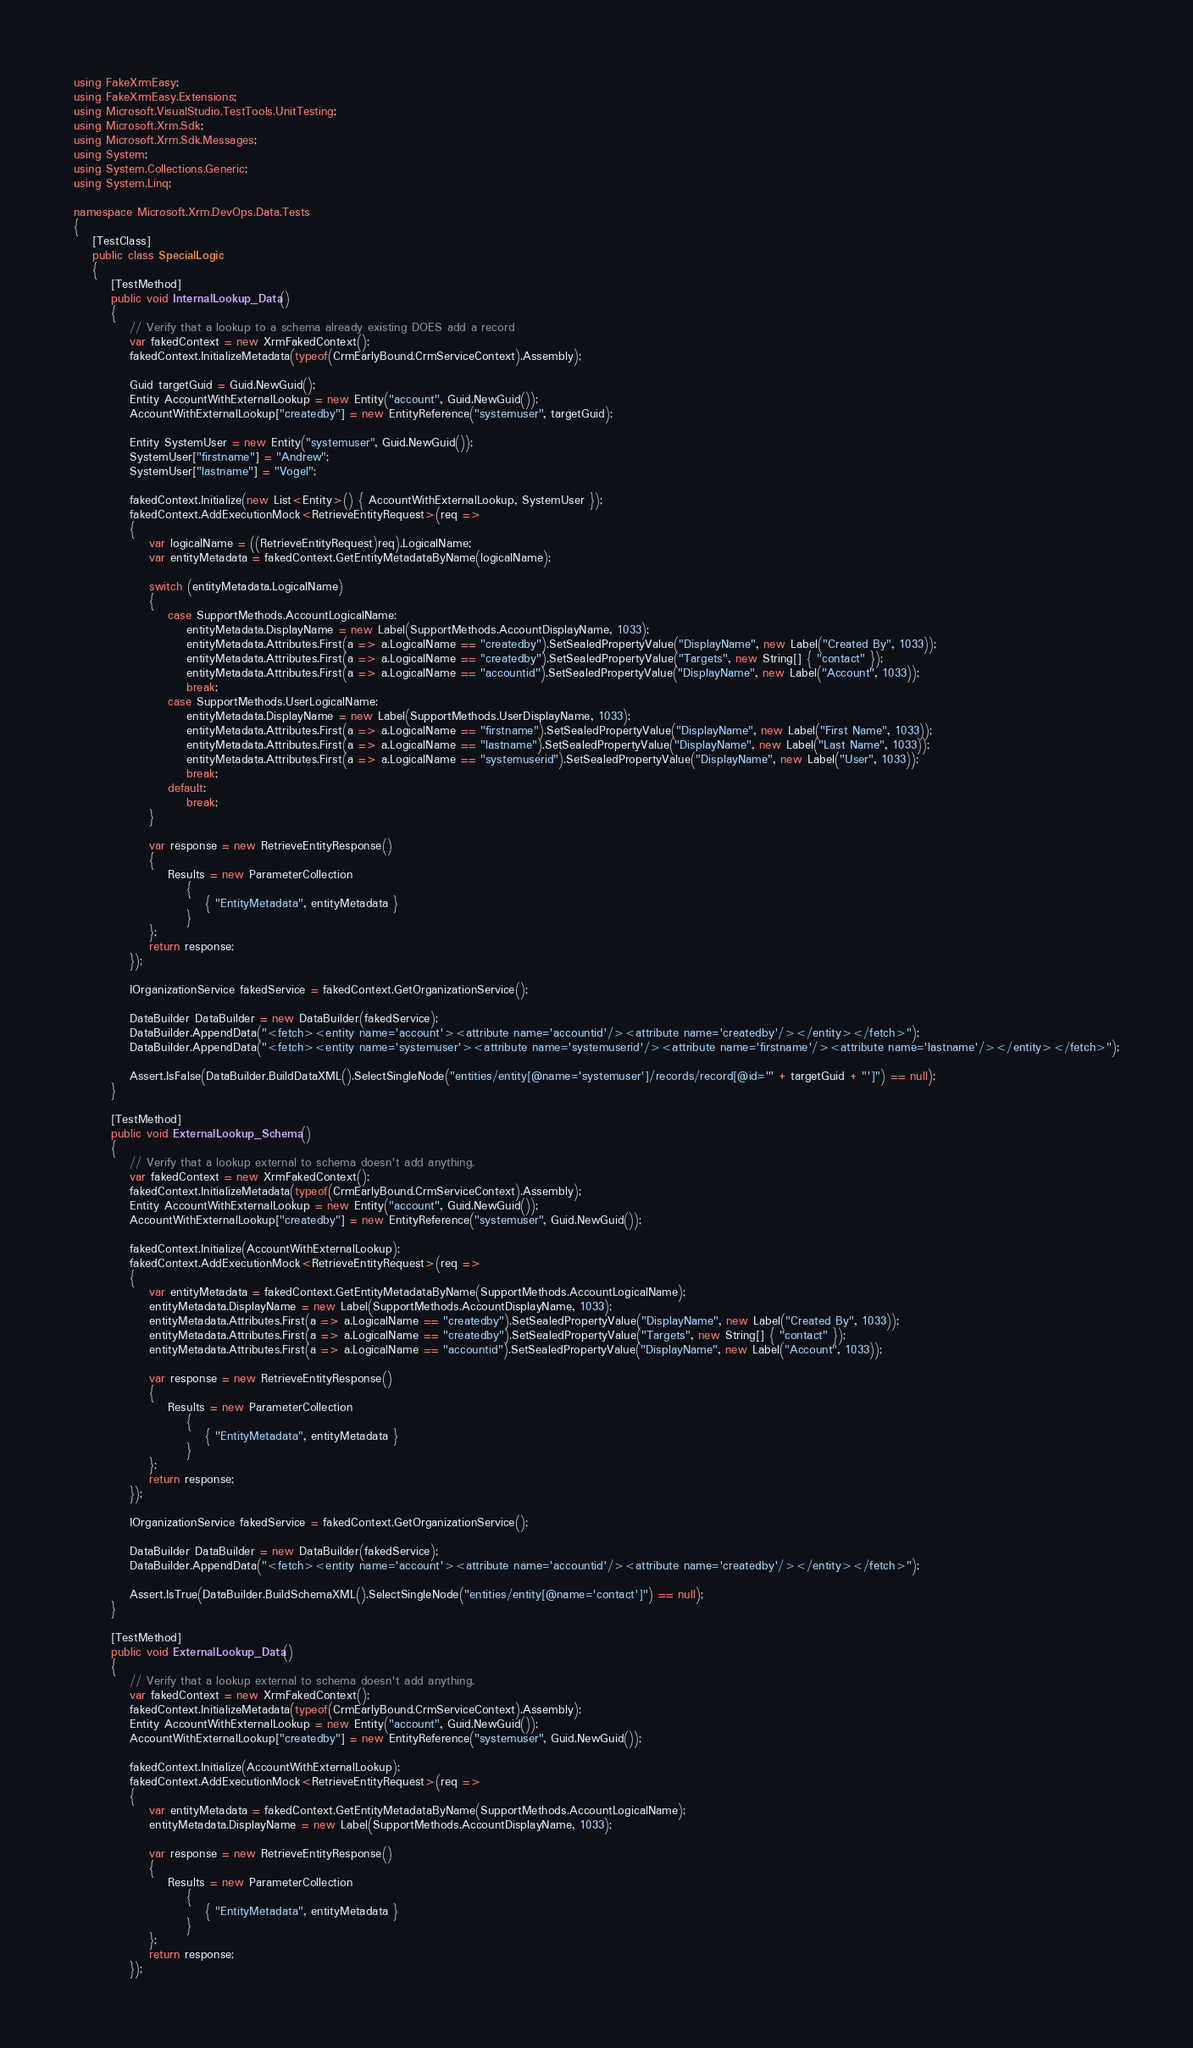<code> <loc_0><loc_0><loc_500><loc_500><_C#_>using FakeXrmEasy;
using FakeXrmEasy.Extensions;
using Microsoft.VisualStudio.TestTools.UnitTesting;
using Microsoft.Xrm.Sdk;
using Microsoft.Xrm.Sdk.Messages;
using System;
using System.Collections.Generic;
using System.Linq;

namespace Microsoft.Xrm.DevOps.Data.Tests
{
    [TestClass]
    public class SpecialLogic
    {
        [TestMethod]
        public void InternalLookup_Data()
        {
            // Verify that a lookup to a schema already existing DOES add a record
            var fakedContext = new XrmFakedContext();
            fakedContext.InitializeMetadata(typeof(CrmEarlyBound.CrmServiceContext).Assembly);

            Guid targetGuid = Guid.NewGuid();
            Entity AccountWithExternalLookup = new Entity("account", Guid.NewGuid());
            AccountWithExternalLookup["createdby"] = new EntityReference("systemuser", targetGuid);

            Entity SystemUser = new Entity("systemuser", Guid.NewGuid());
            SystemUser["firstname"] = "Andrew";
            SystemUser["lastname"] = "Vogel";

            fakedContext.Initialize(new List<Entity>() { AccountWithExternalLookup, SystemUser });
            fakedContext.AddExecutionMock<RetrieveEntityRequest>(req =>
            {
                var logicalName = ((RetrieveEntityRequest)req).LogicalName;
                var entityMetadata = fakedContext.GetEntityMetadataByName(logicalName);

                switch (entityMetadata.LogicalName)
                {
                    case SupportMethods.AccountLogicalName:
                        entityMetadata.DisplayName = new Label(SupportMethods.AccountDisplayName, 1033);
                        entityMetadata.Attributes.First(a => a.LogicalName == "createdby").SetSealedPropertyValue("DisplayName", new Label("Created By", 1033));
                        entityMetadata.Attributes.First(a => a.LogicalName == "createdby").SetSealedPropertyValue("Targets", new String[] { "contact" });
                        entityMetadata.Attributes.First(a => a.LogicalName == "accountid").SetSealedPropertyValue("DisplayName", new Label("Account", 1033));
                        break;
                    case SupportMethods.UserLogicalName:
                        entityMetadata.DisplayName = new Label(SupportMethods.UserDisplayName, 1033);
                        entityMetadata.Attributes.First(a => a.LogicalName == "firstname").SetSealedPropertyValue("DisplayName", new Label("First Name", 1033));
                        entityMetadata.Attributes.First(a => a.LogicalName == "lastname").SetSealedPropertyValue("DisplayName", new Label("Last Name", 1033));
                        entityMetadata.Attributes.First(a => a.LogicalName == "systemuserid").SetSealedPropertyValue("DisplayName", new Label("User", 1033));
                        break;
                    default:
                        break;
                }

                var response = new RetrieveEntityResponse()
                {
                    Results = new ParameterCollection
                        {
                            { "EntityMetadata", entityMetadata }
                        }
                };
                return response;
            });

            IOrganizationService fakedService = fakedContext.GetOrganizationService();

            DataBuilder DataBuilder = new DataBuilder(fakedService);
            DataBuilder.AppendData("<fetch><entity name='account'><attribute name='accountid'/><attribute name='createdby'/></entity></fetch>");
            DataBuilder.AppendData("<fetch><entity name='systemuser'><attribute name='systemuserid'/><attribute name='firstname'/><attribute name='lastname'/></entity></fetch>");

            Assert.IsFalse(DataBuilder.BuildDataXML().SelectSingleNode("entities/entity[@name='systemuser']/records/record[@id='" + targetGuid + "']") == null);
        }

        [TestMethod]
        public void ExternalLookup_Schema()
        {
            // Verify that a lookup external to schema doesn't add anything.
            var fakedContext = new XrmFakedContext();
            fakedContext.InitializeMetadata(typeof(CrmEarlyBound.CrmServiceContext).Assembly);
            Entity AccountWithExternalLookup = new Entity("account", Guid.NewGuid());
            AccountWithExternalLookup["createdby"] = new EntityReference("systemuser", Guid.NewGuid());

            fakedContext.Initialize(AccountWithExternalLookup);
            fakedContext.AddExecutionMock<RetrieveEntityRequest>(req =>
            {
                var entityMetadata = fakedContext.GetEntityMetadataByName(SupportMethods.AccountLogicalName);
                entityMetadata.DisplayName = new Label(SupportMethods.AccountDisplayName, 1033);
                entityMetadata.Attributes.First(a => a.LogicalName == "createdby").SetSealedPropertyValue("DisplayName", new Label("Created By", 1033));
                entityMetadata.Attributes.First(a => a.LogicalName == "createdby").SetSealedPropertyValue("Targets", new String[] { "contact" });
                entityMetadata.Attributes.First(a => a.LogicalName == "accountid").SetSealedPropertyValue("DisplayName", new Label("Account", 1033));

                var response = new RetrieveEntityResponse()
                {
                    Results = new ParameterCollection
                        {
                            { "EntityMetadata", entityMetadata }
                        }
                };
                return response;
            });

            IOrganizationService fakedService = fakedContext.GetOrganizationService();

            DataBuilder DataBuilder = new DataBuilder(fakedService);
            DataBuilder.AppendData("<fetch><entity name='account'><attribute name='accountid'/><attribute name='createdby'/></entity></fetch>");

            Assert.IsTrue(DataBuilder.BuildSchemaXML().SelectSingleNode("entities/entity[@name='contact']") == null);
        }

        [TestMethod]
        public void ExternalLookup_Data()
        {
            // Verify that a lookup external to schema doesn't add anything.
            var fakedContext = new XrmFakedContext();
            fakedContext.InitializeMetadata(typeof(CrmEarlyBound.CrmServiceContext).Assembly);
            Entity AccountWithExternalLookup = new Entity("account", Guid.NewGuid());
            AccountWithExternalLookup["createdby"] = new EntityReference("systemuser", Guid.NewGuid());

            fakedContext.Initialize(AccountWithExternalLookup);
            fakedContext.AddExecutionMock<RetrieveEntityRequest>(req =>
            {
                var entityMetadata = fakedContext.GetEntityMetadataByName(SupportMethods.AccountLogicalName);
                entityMetadata.DisplayName = new Label(SupportMethods.AccountDisplayName, 1033);

                var response = new RetrieveEntityResponse()
                {
                    Results = new ParameterCollection
                        {
                            { "EntityMetadata", entityMetadata }
                        }
                };
                return response;
            });
</code> 